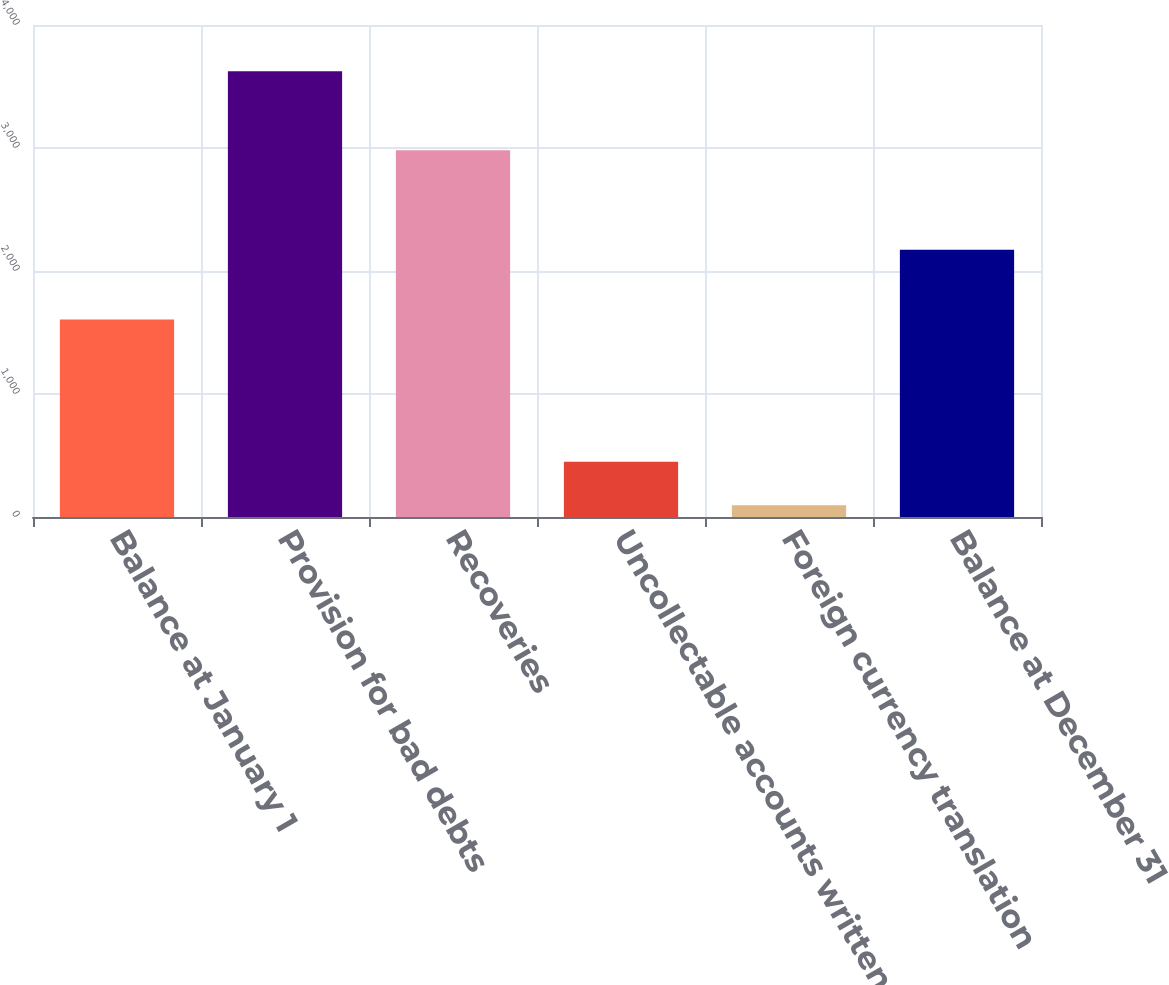Convert chart. <chart><loc_0><loc_0><loc_500><loc_500><bar_chart><fcel>Balance at January 1<fcel>Provision for bad debts<fcel>Recoveries<fcel>Uncollectable accounts written<fcel>Foreign currency translation<fcel>Balance at December 31<nl><fcel>1605<fcel>3623<fcel>2981<fcel>448.7<fcel>96<fcel>2173<nl></chart> 